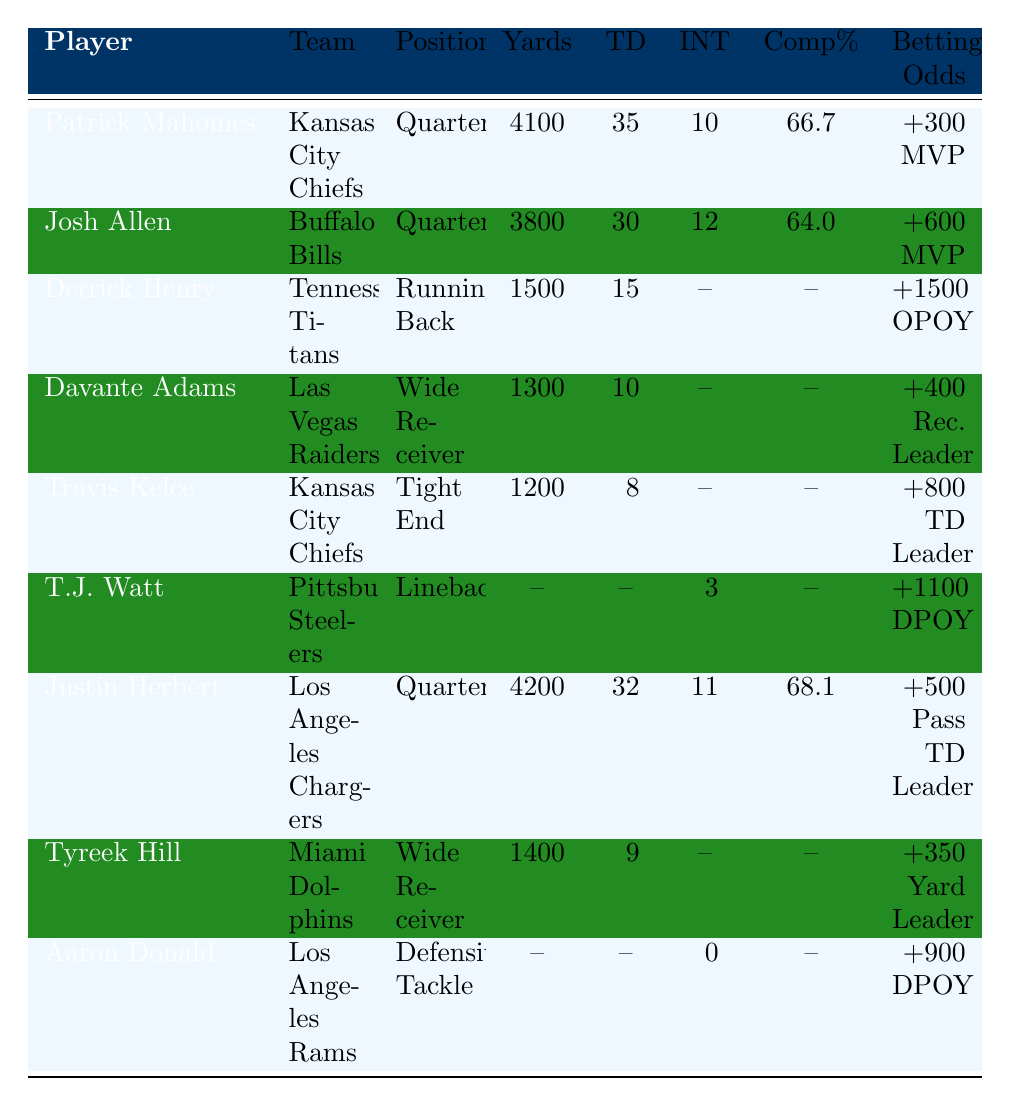What is the total number of touchdowns scored by Patrick Mahomes and Justin Herbert combined? Patrick Mahomes has 35 touchdowns and Justin Herbert has 32 touchdowns. Adding these gives us 35 + 32 = 67.
Answer: 67 Which player has the highest passing yards in the table? Looking at the table, Patrick Mahomes has 4100 passing yards, while Justin Herbert has 4200. Therefore, Justin Herbert has the highest passing yards.
Answer: Justin Herbert Is Davante Adams a quarterback? The table shows that Davante Adams is listed as a Wide Receiver, not a quarterback.
Answer: No Who has the best completion percentage among the quarterbacks in the table? The completion percentages for quarterbacks are Patrick Mahomes at 66.7% and Justin Herbert at 68.1%. Comparing these, Justin Herbert has the better completion percentage.
Answer: Justin Herbert What is the difference in rushing yards between Derrick Henry and Justin Herbert's passing yards? Derrick Henry has 1500 rushing yards while Justin Herbert has 4200 passing yards. To find the difference, we calculate 4200 - 1500 = 2700.
Answer: 2700 Which player has the lowest betting odds for MVP? The table shows that Patrick Mahomes has the lowest odds at +300 for MVP, while Josh Allen has +600. Therefore, Patrick Mahomes has the lowest betting odds.
Answer: Patrick Mahomes What are the combined receiving yards of Davante Adams and Tyreek Hill? Davante Adams has 1300 receiving yards and Tyreek Hill has 1400 receiving yards. Adding these gives 1300 + 1400 = 2700.
Answer: 2700 How many players have 10 or more sacks based on the table? T.J. Watt has 15 sacks, and Aaron Donald has 10 sacks. Both have 10 or more sacks, which gives us a total of 2 players.
Answer: 2 Which position has the highest average touchdowns among the players listed? The players with touchdowns are Patrick Mahomes (35), Josh Allen (30), Derrick Henry (15), Davante Adams (10), Travis Kelce (8), and Justin Herbert (32). The average can be calculated as (35 + 30 + 15 + 10 + 8 + 32) / 6 = 15.
Answer: 15 Is T.J. Watt the only player listed without any touchdowns? The table shows that T.J. Watt’s statistics do not include touchdowns, while Derrick Henry has rushing touchdowns and others have receiving touchdowns. Thus, T.J. Watt does not have touchdowns, but he is not the only one.
Answer: No 